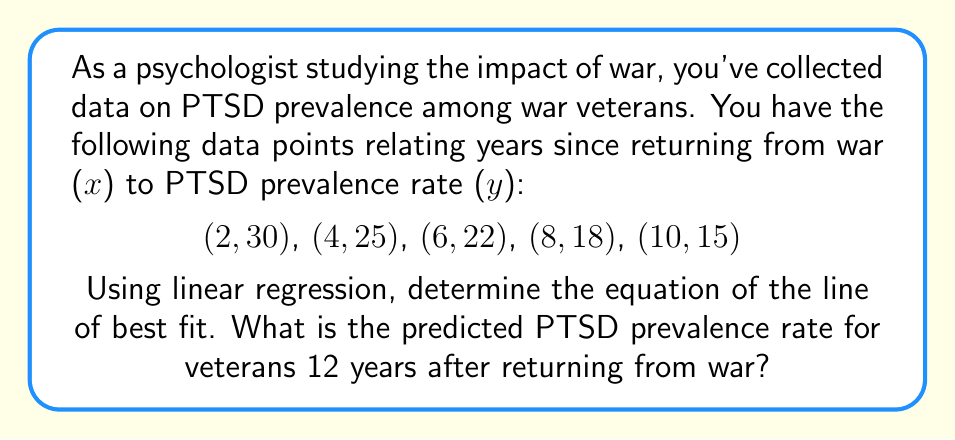Provide a solution to this math problem. 1. To find the line of best fit using linear regression, we'll use the formula:
   $$y = mx + b$$
   where $m$ is the slope and $b$ is the y-intercept.

2. Calculate the means of x and y:
   $$\bar{x} = \frac{2 + 4 + 6 + 8 + 10}{5} = 6$$
   $$\bar{y} = \frac{30 + 25 + 22 + 18 + 15}{5} = 22$$

3. Calculate the slope (m) using the formula:
   $$m = \frac{\sum(x_i - \bar{x})(y_i - \bar{y})}{\sum(x_i - \bar{x})^2}$$

   $$m = \frac{(-4)(-8) + (-2)(-3) + (0)(0) + (2)(4) + (4)(7)}{(-4)^2 + (-2)^2 + (0)^2 + (2)^2 + (4)^2}$$
   $$m = \frac{32 + 6 + 0 + 8 + 28}{16 + 4 + 0 + 4 + 16} = \frac{74}{40} = -1.85$$

4. Calculate the y-intercept (b) using the formula:
   $$b = \bar{y} - m\bar{x}$$
   $$b = 22 - (-1.85)(6) = 33.1$$

5. The equation of the line of best fit is:
   $$y = -1.85x + 33.1$$

6. To predict the PTSD prevalence rate for veterans 12 years after returning:
   $$y = -1.85(12) + 33.1 = 10.9$$
Answer: 10.9% 